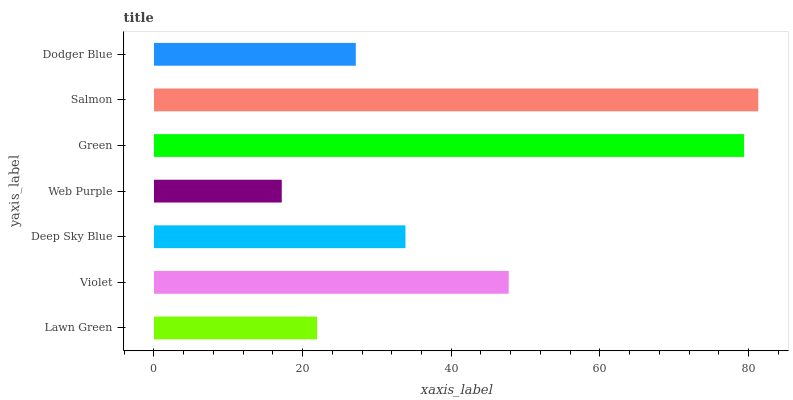Is Web Purple the minimum?
Answer yes or no. Yes. Is Salmon the maximum?
Answer yes or no. Yes. Is Violet the minimum?
Answer yes or no. No. Is Violet the maximum?
Answer yes or no. No. Is Violet greater than Lawn Green?
Answer yes or no. Yes. Is Lawn Green less than Violet?
Answer yes or no. Yes. Is Lawn Green greater than Violet?
Answer yes or no. No. Is Violet less than Lawn Green?
Answer yes or no. No. Is Deep Sky Blue the high median?
Answer yes or no. Yes. Is Deep Sky Blue the low median?
Answer yes or no. Yes. Is Salmon the high median?
Answer yes or no. No. Is Salmon the low median?
Answer yes or no. No. 